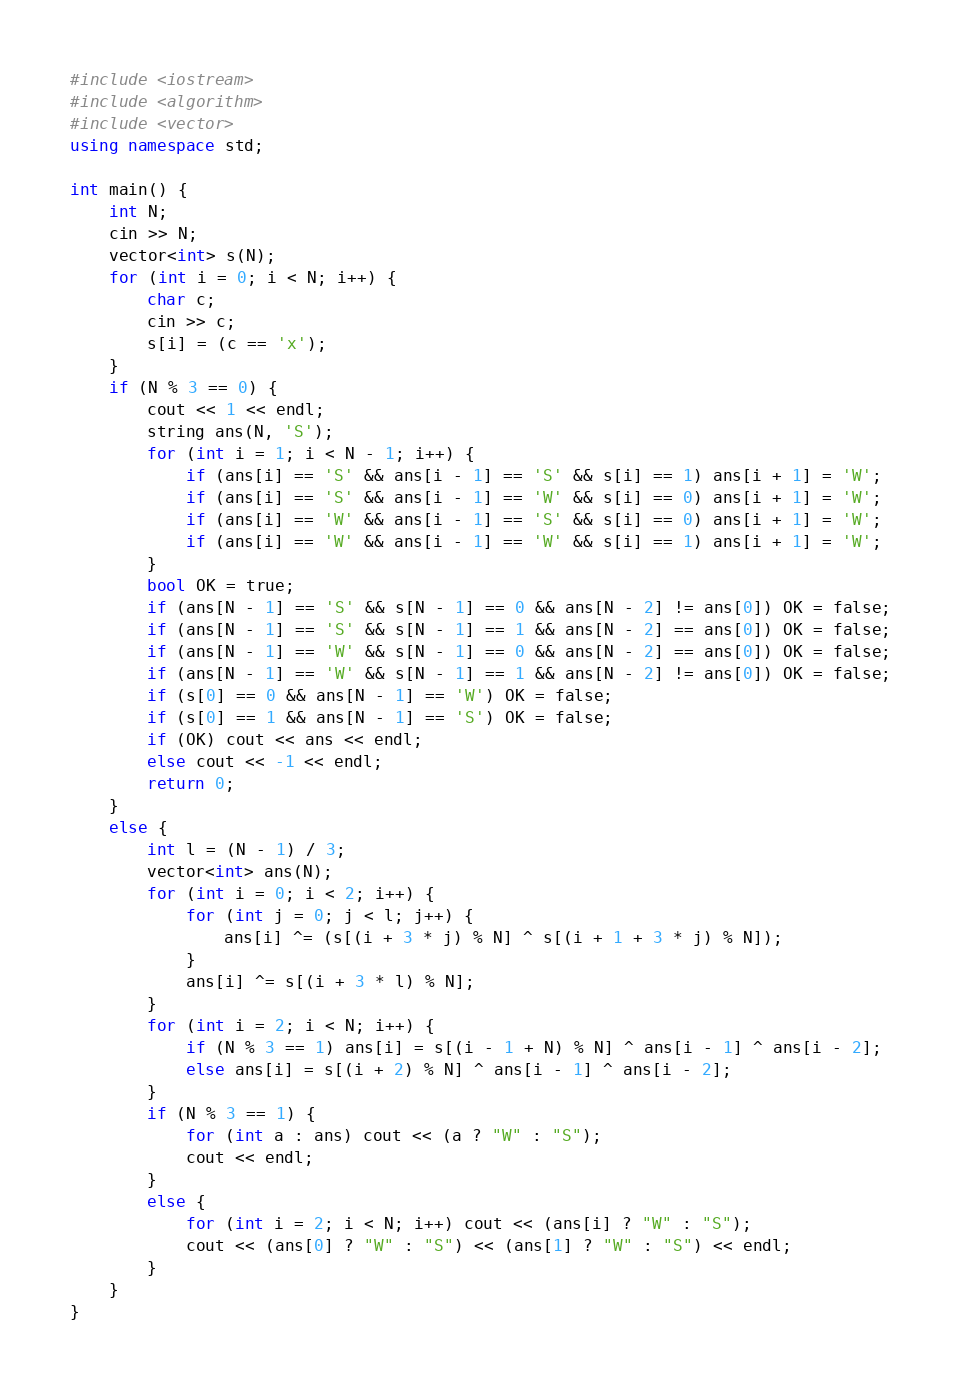Convert code to text. <code><loc_0><loc_0><loc_500><loc_500><_C++_>#include <iostream>
#include <algorithm>
#include <vector>
using namespace std;

int main() {
	int N;
	cin >> N;
	vector<int> s(N);
	for (int i = 0; i < N; i++) {
		char c;
		cin >> c;
		s[i] = (c == 'x');
	}
	if (N % 3 == 0) {
		cout << 1 << endl;
		string ans(N, 'S');
		for (int i = 1; i < N - 1; i++) {
			if (ans[i] == 'S' && ans[i - 1] == 'S' && s[i] == 1) ans[i + 1] = 'W';
			if (ans[i] == 'S' && ans[i - 1] == 'W' && s[i] == 0) ans[i + 1] = 'W';
			if (ans[i] == 'W' && ans[i - 1] == 'S' && s[i] == 0) ans[i + 1] = 'W';
			if (ans[i] == 'W' && ans[i - 1] == 'W' && s[i] == 1) ans[i + 1] = 'W';
		}
		bool OK = true;
		if (ans[N - 1] == 'S' && s[N - 1] == 0 && ans[N - 2] != ans[0]) OK = false;
		if (ans[N - 1] == 'S' && s[N - 1] == 1 && ans[N - 2] == ans[0]) OK = false;
		if (ans[N - 1] == 'W' && s[N - 1] == 0 && ans[N - 2] == ans[0]) OK = false;
		if (ans[N - 1] == 'W' && s[N - 1] == 1 && ans[N - 2] != ans[0]) OK = false;
		if (s[0] == 0 && ans[N - 1] == 'W') OK = false;
		if (s[0] == 1 && ans[N - 1] == 'S') OK = false;
		if (OK) cout << ans << endl;
		else cout << -1 << endl;
		return 0;
	}
	else {
		int l = (N - 1) / 3;
		vector<int> ans(N);
		for (int i = 0; i < 2; i++) {
			for (int j = 0; j < l; j++) {
				ans[i] ^= (s[(i + 3 * j) % N] ^ s[(i + 1 + 3 * j) % N]);
			}
			ans[i] ^= s[(i + 3 * l) % N];
		}
		for (int i = 2; i < N; i++) {
			if (N % 3 == 1) ans[i] = s[(i - 1 + N) % N] ^ ans[i - 1] ^ ans[i - 2];
			else ans[i] = s[(i + 2) % N] ^ ans[i - 1] ^ ans[i - 2];
		}
		if (N % 3 == 1) {
			for (int a : ans) cout << (a ? "W" : "S");
			cout << endl;
		}
		else {
			for (int i = 2; i < N; i++) cout << (ans[i] ? "W" : "S");
			cout << (ans[0] ? "W" : "S") << (ans[1] ? "W" : "S") << endl;
		}
	}
}</code> 